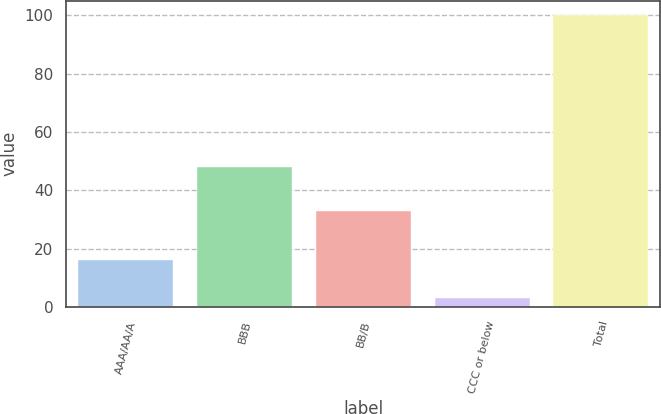Convert chart to OTSL. <chart><loc_0><loc_0><loc_500><loc_500><bar_chart><fcel>AAA/AA/A<fcel>BBB<fcel>BB/B<fcel>CCC or below<fcel>Total<nl><fcel>16<fcel>48<fcel>33<fcel>3<fcel>100<nl></chart> 